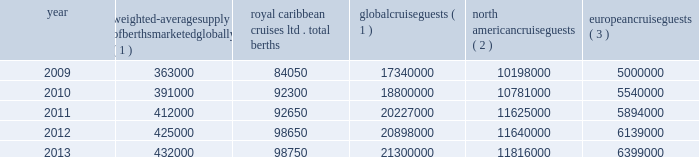Part i the table details the growth in global weighted average berths and the global , north american and european cruise guests over the past five years : weighted-average supply of berths marketed globally ( 1 ) royal caribbean cruises ltd .
Total berths global cruise guests ( 1 ) north american cruise guests ( 2 ) european cruise guests ( 3 ) .
( 1 ) source : our estimates of the number of global cruise guests and the weighted-average supply of berths marketed globally are based on a com- bination of data that we obtain from various publicly available cruise industry trade information sources including seatrade insider , cruise industry news and cruise line international association ( 201cclia 201d ) .
In addition , our estimates incorporate our own statistical analysis utilizing the same publicly available cruise industry data as a base .
( 2 ) source : cruise line international association based on cruise guests carried for at least two consecutive nights for years 2009 through 2012 .
Year 2013 amounts represent our estimates ( see number 1 above ) .
Includes the united states of america and canada .
( 3 ) source : clia europe , formerly european cruise council , for years 2009 through 2012 .
Year 2013 amounts represent our estimates ( see number 1 above ) .
North america the majority of cruise guests are sourced from north america , which represented approximately 56% ( 56 % ) of global cruise guests in 2013 .
The compound annual growth rate in cruise guests sourced from this market was approximately 3.2% ( 3.2 % ) from 2009 to 2013 .
Europe cruise guests sourced from europe represented approximately 30% ( 30 % ) of global cruise guests in 2013 .
The compound annual growth rate in cruise guests sourced from this market was approximately 6.0% ( 6.0 % ) from 2009 to 2013 .
Other markets in addition to expected industry growth in north america and europe , we expect the asia/pacific region to demonstrate an even higher growth rate in the near term , although it will continue to represent a relatively small sector compared to north america and europe .
Based on industry data , cruise guests sourced from the asia/pacific region represented approximately 4.5% ( 4.5 % ) of global cruise guests in 2013 .
The compound annual growth rate in cruise guests sourced from this market was approximately 15% ( 15 % ) from 2011 to 2013 .
Competition we compete with a number of cruise lines .
Our princi- pal competitors are carnival corporation & plc , which owns , among others , aida cruises , carnival cruise lines , costa cruises , cunard line , holland america line , iberocruceros , p&o cruises and princess cruises ; disney cruise line ; msc cruises ; norwegian cruise line and oceania cruises .
Cruise lines compete with other vacation alternatives such as land-based resort hotels and sightseeing destinations for consumers 2019 leisure time .
Demand for such activities is influenced by political and general economic conditions .
Com- panies within the vacation market are dependent on consumer discretionary spending .
Operating strategies our principal operating strategies are to : and employees and protect the environment in which our vessels and organization operate , to better serve our global guest base and grow our business , order to enhance our revenues , our brands globally , expenditures and ensure adequate cash and liquid- ity , with the overall goal of maximizing our return on invested capital and long-term shareholder value , ization and maintenance of existing ships and the transfer of key innovations across each brand , while prudently expanding our fleet with new state-of- the-art cruise ships , ships by deploying them into those markets and itineraries that provide opportunities to optimize returns , while continuing our focus on existing key markets , service customer preferences and expectations in an innovative manner , while supporting our strategic focus on profitability , and .
How many of the total global cruise guests are not from north america or europe? 
Rationale: "other" is not listed so subtract total na and total eur
Computations: (21300000 - (11816000 + 6399000))
Answer: 3085000.0. 